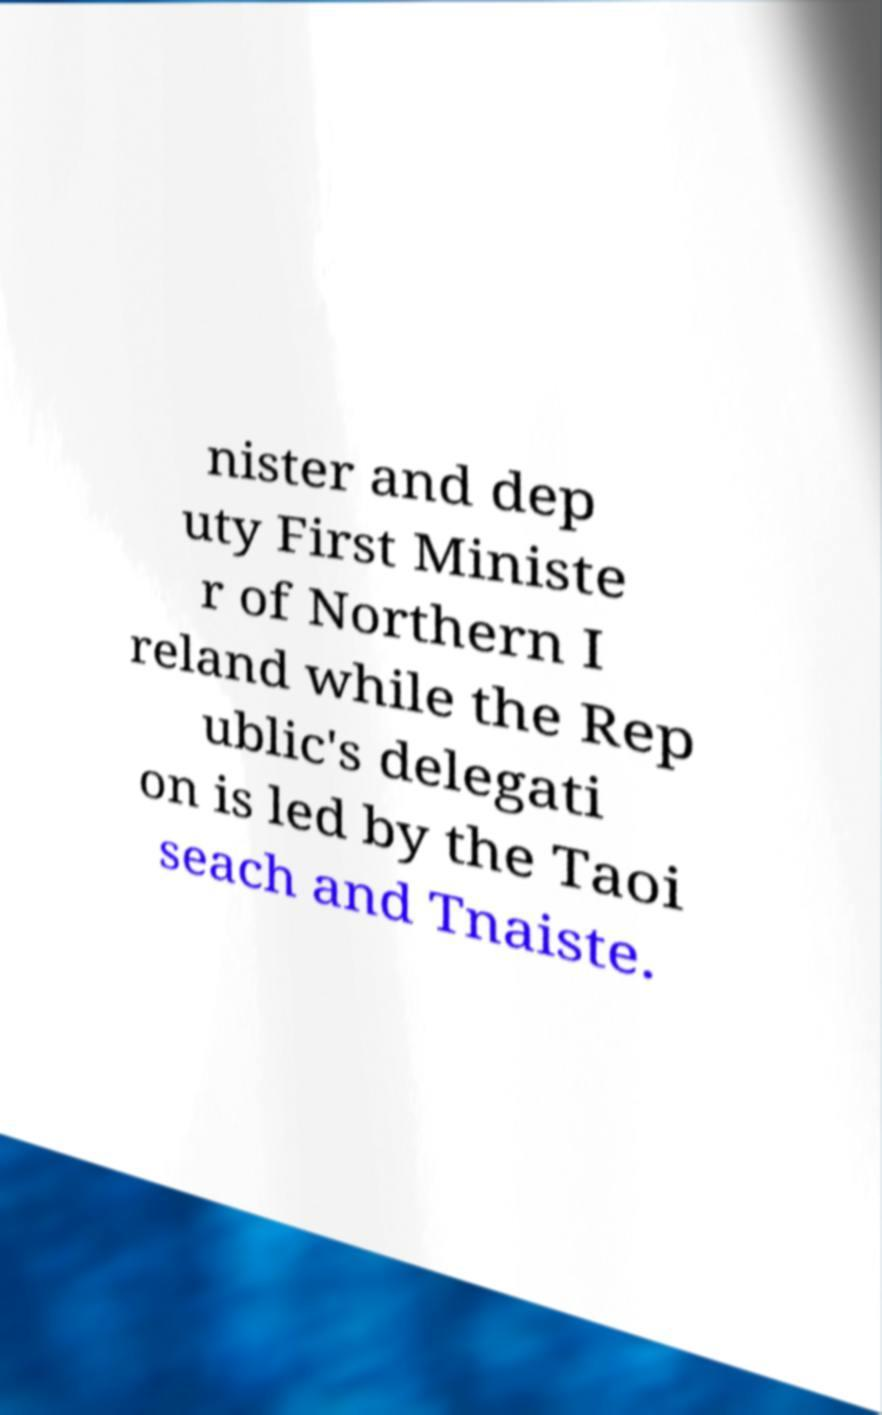Can you accurately transcribe the text from the provided image for me? nister and dep uty First Ministe r of Northern I reland while the Rep ublic's delegati on is led by the Taoi seach and Tnaiste. 